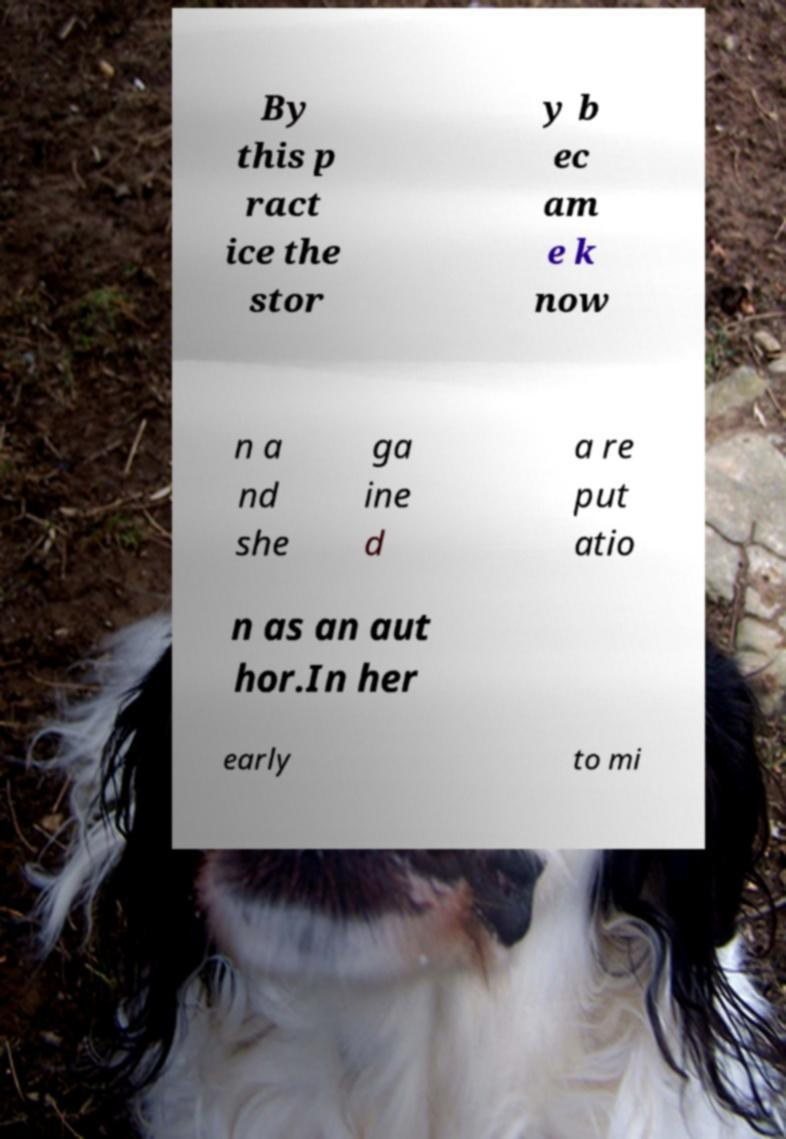Can you read and provide the text displayed in the image?This photo seems to have some interesting text. Can you extract and type it out for me? By this p ract ice the stor y b ec am e k now n a nd she ga ine d a re put atio n as an aut hor.In her early to mi 